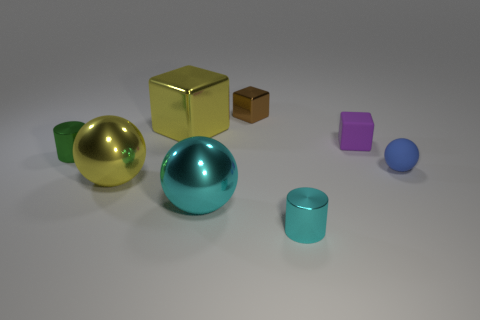Is the number of green cylinders right of the brown cube less than the number of small cubes behind the small rubber block?
Your answer should be very brief. Yes. Are there any other things that are the same shape as the purple object?
Offer a terse response. Yes. There is a object that is the same color as the big metallic cube; what is it made of?
Provide a short and direct response. Metal. How many small blue rubber balls are behind the block that is to the right of the tiny block to the left of the small purple block?
Ensure brevity in your answer.  0. How many blue matte spheres are in front of the blue rubber thing?
Make the answer very short. 0. What number of large yellow objects have the same material as the large yellow ball?
Offer a terse response. 1. What is the color of the cylinder that is made of the same material as the tiny cyan thing?
Your answer should be compact. Green. The tiny cylinder that is to the right of the small metal cylinder that is behind the tiny cylinder that is in front of the tiny green cylinder is made of what material?
Provide a succinct answer. Metal. There is a cylinder to the right of the cyan sphere; does it have the same size as the large yellow cube?
Ensure brevity in your answer.  No. What number of big objects are gray shiny cylinders or green cylinders?
Your answer should be very brief. 0. 